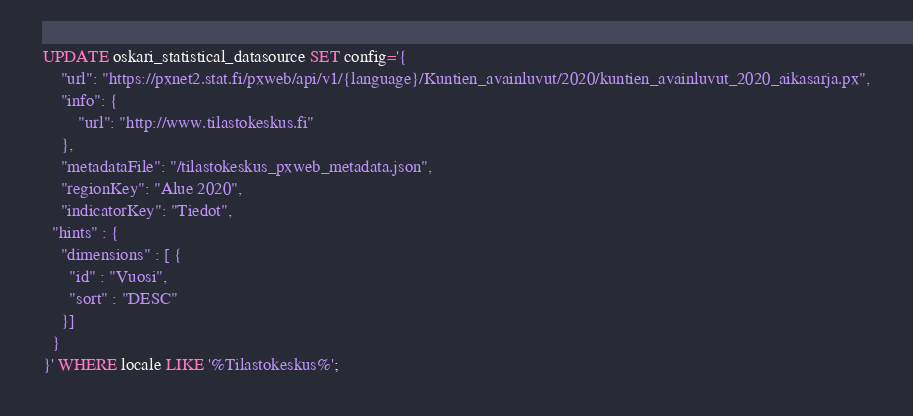Convert code to text. <code><loc_0><loc_0><loc_500><loc_500><_SQL_>UPDATE oskari_statistical_datasource SET config='{
	"url": "https://pxnet2.stat.fi/pxweb/api/v1/{language}/Kuntien_avainluvut/2020/kuntien_avainluvut_2020_aikasarja.px",
	"info": {
		"url": "http://www.tilastokeskus.fi"
	},
	"metadataFile": "/tilastokeskus_pxweb_metadata.json",
	"regionKey": "Alue 2020",
	"indicatorKey": "Tiedot",
  "hints" : {
    "dimensions" : [ {
      "id" : "Vuosi",
      "sort" : "DESC"
    }]
  }
}' WHERE locale LIKE '%Tilastokeskus%';
</code> 